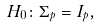<formula> <loc_0><loc_0><loc_500><loc_500>H _ { 0 } \colon \Sigma _ { p } = I _ { p } ,</formula> 